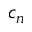Convert formula to latex. <formula><loc_0><loc_0><loc_500><loc_500>c _ { n }</formula> 